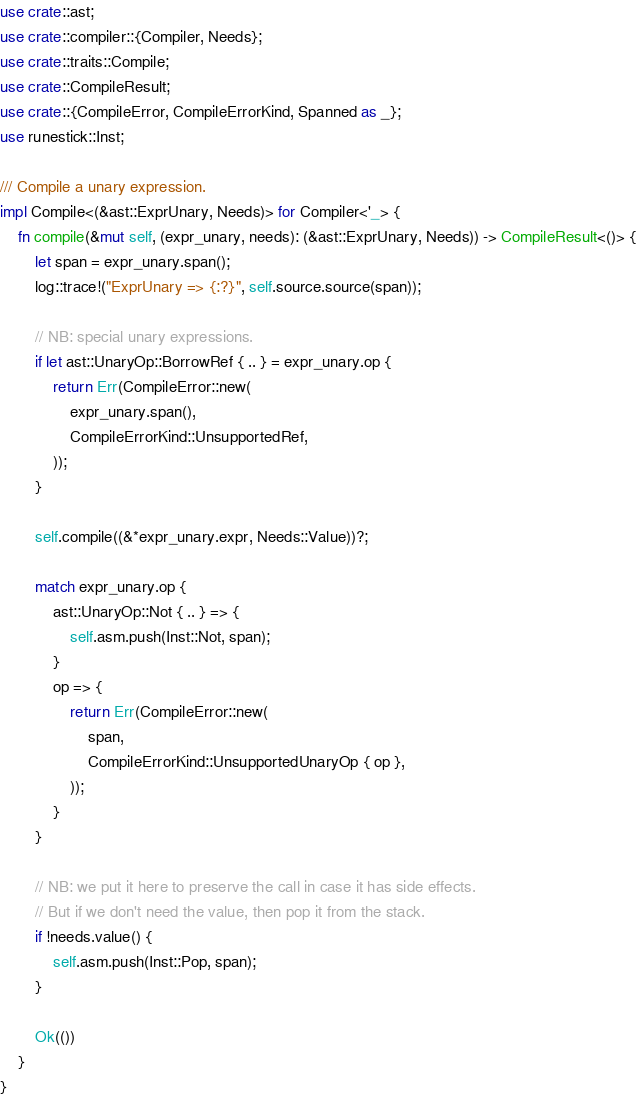<code> <loc_0><loc_0><loc_500><loc_500><_Rust_>use crate::ast;
use crate::compiler::{Compiler, Needs};
use crate::traits::Compile;
use crate::CompileResult;
use crate::{CompileError, CompileErrorKind, Spanned as _};
use runestick::Inst;

/// Compile a unary expression.
impl Compile<(&ast::ExprUnary, Needs)> for Compiler<'_> {
    fn compile(&mut self, (expr_unary, needs): (&ast::ExprUnary, Needs)) -> CompileResult<()> {
        let span = expr_unary.span();
        log::trace!("ExprUnary => {:?}", self.source.source(span));

        // NB: special unary expressions.
        if let ast::UnaryOp::BorrowRef { .. } = expr_unary.op {
            return Err(CompileError::new(
                expr_unary.span(),
                CompileErrorKind::UnsupportedRef,
            ));
        }

        self.compile((&*expr_unary.expr, Needs::Value))?;

        match expr_unary.op {
            ast::UnaryOp::Not { .. } => {
                self.asm.push(Inst::Not, span);
            }
            op => {
                return Err(CompileError::new(
                    span,
                    CompileErrorKind::UnsupportedUnaryOp { op },
                ));
            }
        }

        // NB: we put it here to preserve the call in case it has side effects.
        // But if we don't need the value, then pop it from the stack.
        if !needs.value() {
            self.asm.push(Inst::Pop, span);
        }

        Ok(())
    }
}
</code> 